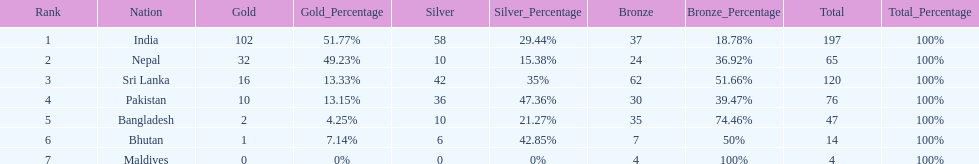How many countries have one more than 10 gold medals? 3. 